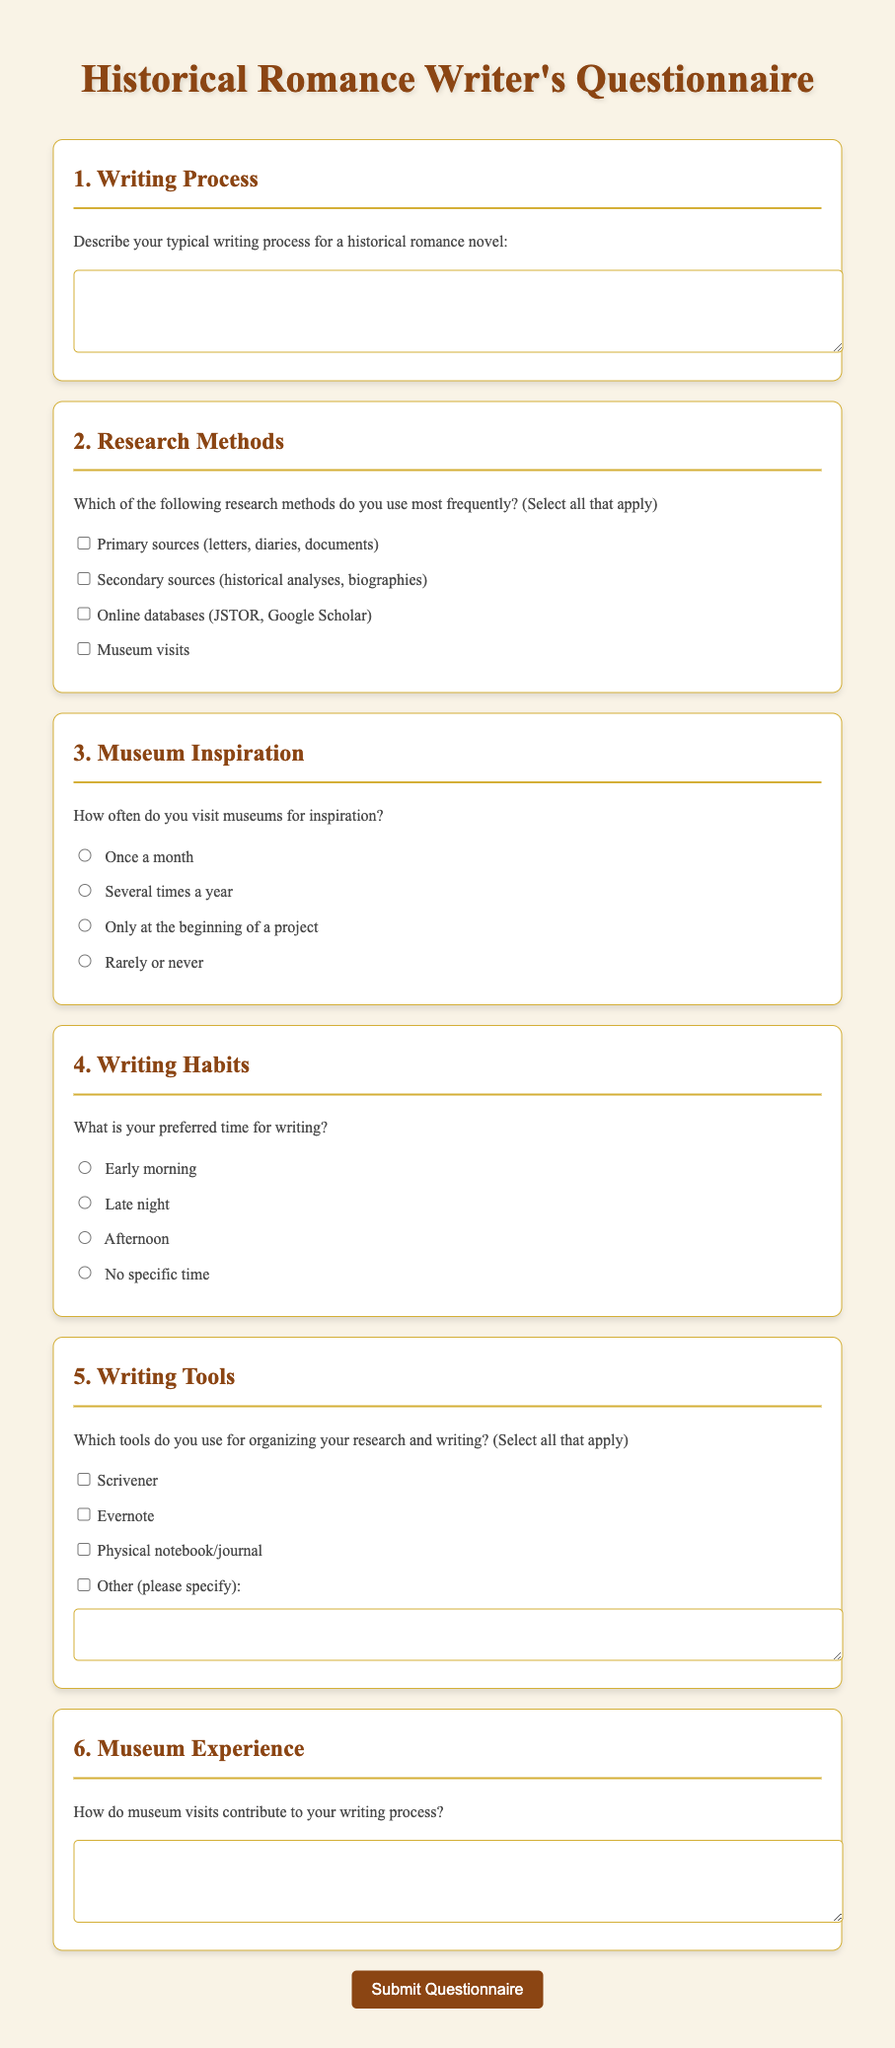What is the title of the document? The title is displayed prominently at the top of the document.
Answer: Historical Romance Writer's Questionnaire What is the color of the text in the document? The document specifies the color of text in the styling section.
Answer: #4a4a4a How many question sections are in the document? The document lists several sections, each focusing on different aspects of the writing process.
Answer: 6 What input type is used for the museum frequency question? The document describes the type of input for this specific question.
Answer: radio Which writing tool is mentioned first in the tools section? The document lists the options available for organizing research and writing.
Answer: Scrivener What frequency option is provided for museum visits in the questionnaire? The questionnaire includes various responses for how often writers visit museums.
Answer: Several times a year What is the required length of the textarea for describing how museum visits contribute to the writing process? The document specifies the height of the textarea as part of the form design.
Answer: 4 rows 